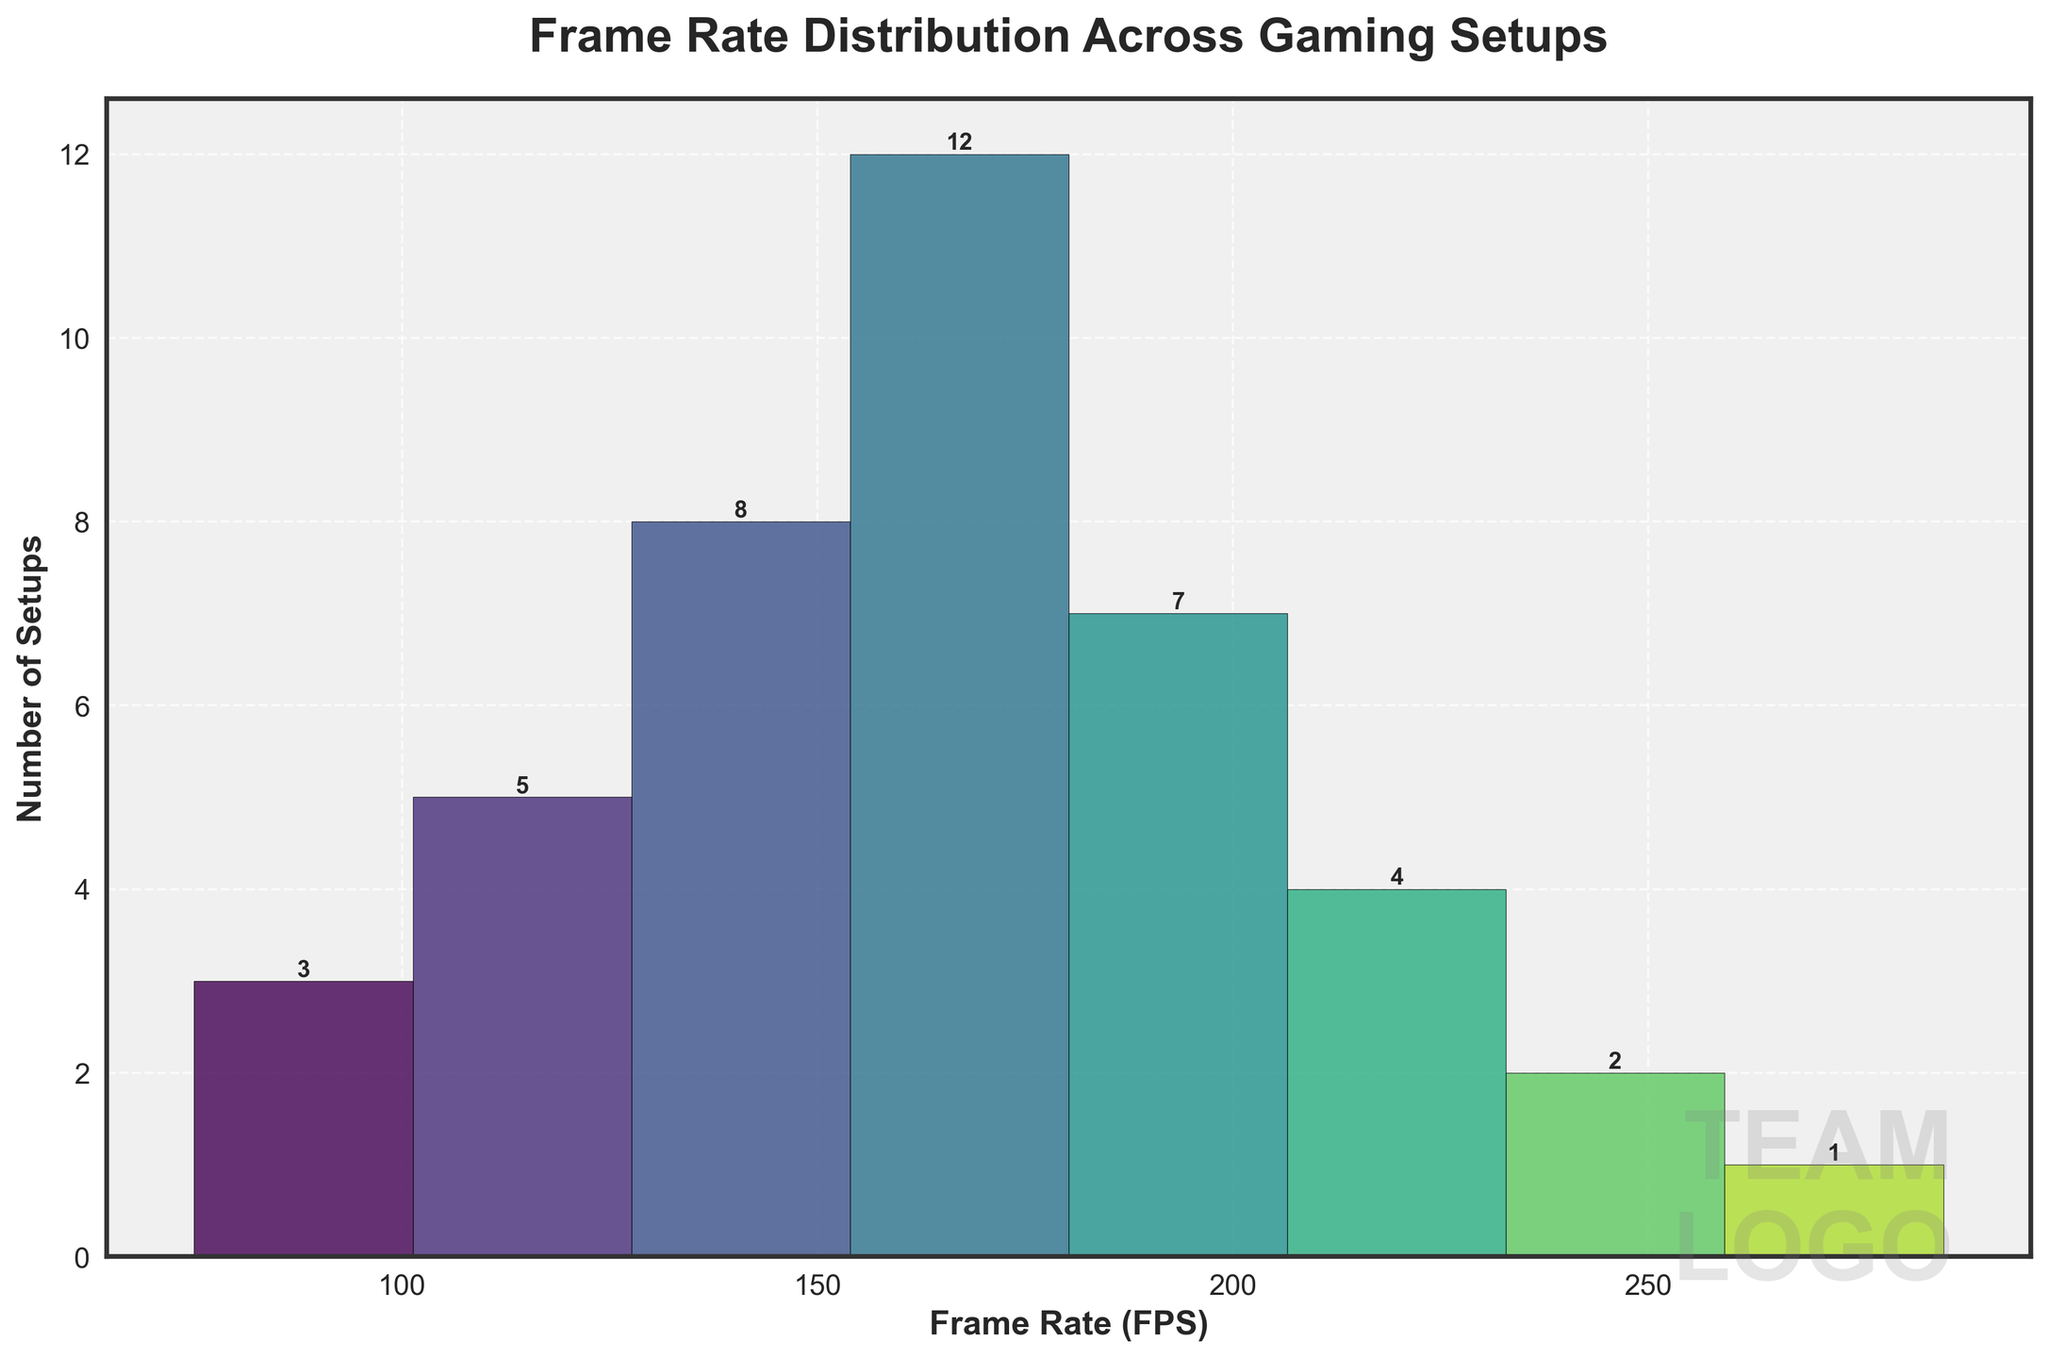What is the title of the histogram? The title of the histogram is usually found at the top center of the figure. In this case, refer to the text placed above the plot area.
Answer: Frame Rate Distribution Across Gaming Setups What is on the x-axis of the histogram? The x-axis label is typically the bottom label of the plot which explains what the horizontal scale represents. Here, it is labeled.
Answer: Frame Rate (FPS) Which frame rate range has the highest count of setups? By looking at the tallest bar in the histogram and checking its respective frame rate range, we can identify the frame rate range with the highest frequency.
Answer: 151-180 How many setups have a frame rate between 181 and 210 FPS? Look at the bar corresponding to the frame rate range of 181-210 FPS and read the value indicated either by height or the number labeled at the top of the bar.
Answer: 7 What is the total count of gaming setups recorded in the histogram? To get the total count, sum up all the setup counts represented by all bars in the histogram. That is, adding 3 + 5 + 8 + 12 + 7 + 4 + 2 + 1.
Answer: 42 Which frame rate range has the lowest count of setups? By identifying the shortest bar in the histogram and checking its frame rate range, we determine the range with the lowest frequency.
Answer: 271-300 What is the average frame rate of the gaming setups? First, compute the midpoint of each range to approximate the frame rates: (60+90)/2, (91+120)/2, etc. Then, weigh these midpoints by their respective counts and divide by the total number of setups.
Answer: Roughly 161.1 FPS Which two frame rate ranges have counts that differ by exactly one setup? Compare the counts of each neighboring bar and find pairs with a count difference of one. In this case, 211-240 (4) and 241-270 (2) fit the criteria with a difference of 2. Also pair 181-210 (7) and 211-240 (4) have a difference of 3 setups. So there is pair 181-210 (7) and 211-240 (4).
Answer: 181-210 and 211-240 